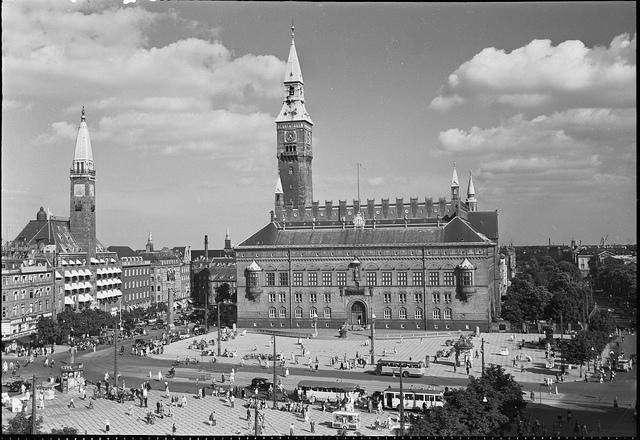How many kites are in the picture?
Give a very brief answer. 0. 